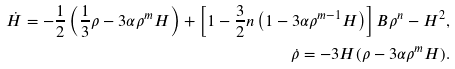<formula> <loc_0><loc_0><loc_500><loc_500>\dot { H } = - \frac { 1 } { 2 } \left ( \frac { 1 } { 3 } \rho - 3 \alpha \rho ^ { m } H \right ) + \left [ 1 - \frac { 3 } { 2 } n \left ( 1 - 3 \alpha \rho ^ { m - 1 } H \right ) \right ] B \rho ^ { n } - H ^ { 2 } , \\ \dot { \rho } = - 3 H ( \rho - 3 \alpha \rho ^ { m } H ) .</formula> 